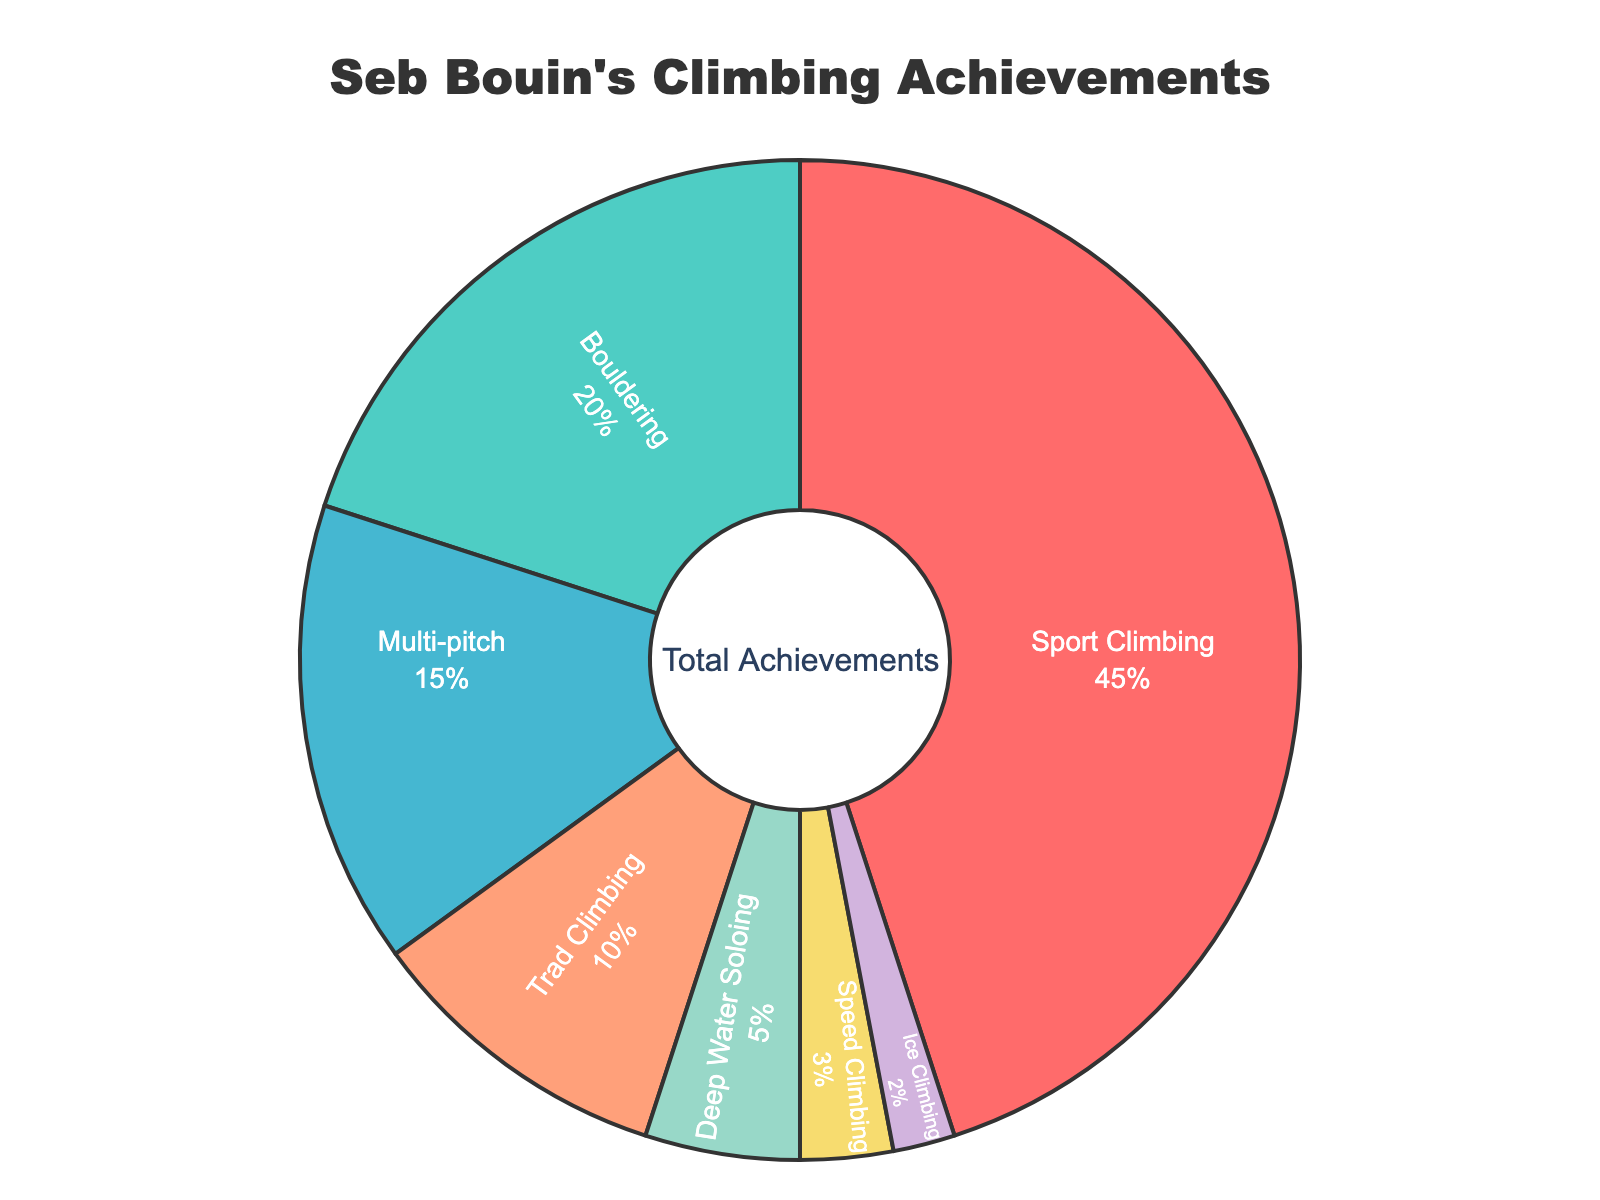What percentage of Seb Bouin's achievements are in sport climbing? Sport climbing accounts for 45% as marked directly on the pie chart.
Answer: 45% Which discipline has the smallest percentage of Seb Bouin's achievements? By looking at the chart, ice climbing has the smallest segment at 2%.
Answer: Ice Climbing How much greater is the percentage of sport climbing compared to deep water soloing? Sport climbing is 45% and deep water soloing is 5%. The difference is 45% - 5% = 40%.
Answer: 40% What is the combined percentage of multi-pitch and trad climbing achievements? Multi-pitch climbing is 15% and trad climbing is 10%. Their combined percentage is 15% + 10% = 25%.
Answer: 25% Which discipline has a greater percentage of achievements, bouldering or speed climbing? Bouldering has 20% while speed climbing has 3%. Bouldering has a greater percentage.
Answer: Bouldering How many disciplines have a higher percentage than trad climbing? Sport climbing (45%), bouldering (20%), and multi-pitch (15%) all have a higher percentage than trad climbing which is 10%. In total, there are 3 disciplines.
Answer: 3 What visual feature is used to distinguish between different disciplines in the pie chart? Different colors are used for each discipline to differentiate them visually in the pie chart.
Answer: Colors By what factor is sport climbing greater than ice climbing in terms of percentage? Sport climbing (45%) is greater than ice climbing (2%). The factor is 45% ÷ 2% = 22.5.
Answer: 22.5 If you sum the percentages of speed climbing, ice climbing, and deep water soloing, what is the total? Speed climbing is 3%, ice climbing is 2%, and deep water soloing is 5%. Their total is 3% + 2% + 5% = 10%.
Answer: 10% 